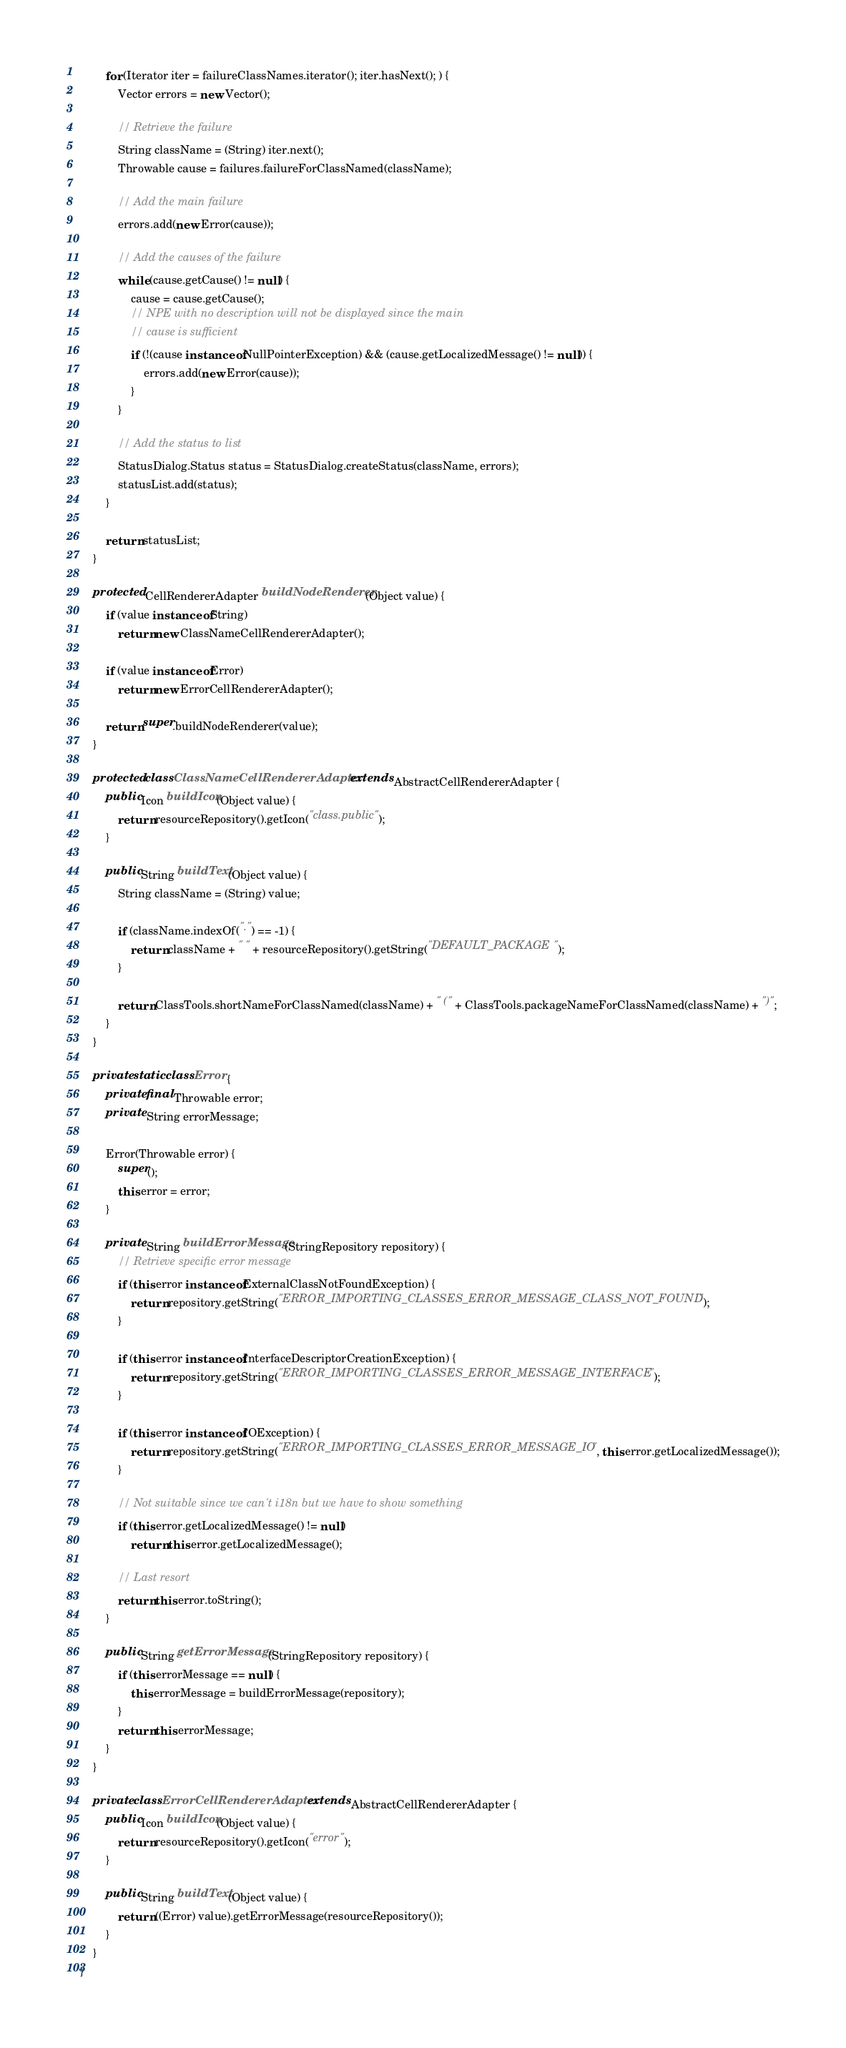<code> <loc_0><loc_0><loc_500><loc_500><_Java_>		for (Iterator iter = failureClassNames.iterator(); iter.hasNext(); ) {
			Vector errors = new Vector();

			// Retrieve the failure
			String className = (String) iter.next();
			Throwable cause = failures.failureForClassNamed(className);

			// Add the main failure
			errors.add(new Error(cause));

			// Add the causes of the failure
			while (cause.getCause() != null) {
				cause = cause.getCause();
				// NPE with no description will not be displayed since the main
				// cause is sufficient
				if (!(cause instanceof NullPointerException) && (cause.getLocalizedMessage() != null)) {
					errors.add(new Error(cause));
				}
			}

			// Add the status to list
			StatusDialog.Status status = StatusDialog.createStatus(className, errors);
			statusList.add(status);
		}

		return statusList;
	}

	protected CellRendererAdapter buildNodeRenderer(Object value) {
		if (value instanceof String)
			return new ClassNameCellRendererAdapter();

		if (value instanceof Error)
			return new ErrorCellRendererAdapter();

		return super.buildNodeRenderer(value);
	}

	protected class ClassNameCellRendererAdapter extends AbstractCellRendererAdapter {
		public Icon buildIcon(Object value) {
			return resourceRepository().getIcon("class.public");
		}

		public String buildText(Object value) {
			String className = (String) value;

			if (className.indexOf(".") == -1) {
				return className + " " + resourceRepository().getString("DEFAULT_PACKAGE");
			}

			return ClassTools.shortNameForClassNamed(className) + " (" + ClassTools.packageNameForClassNamed(className) + ")";
		}
	}

	private static class Error {
		private final Throwable error;
		private String errorMessage;

		Error(Throwable error) {
			super();
			this.error = error;
		}

		private String buildErrorMessage(StringRepository repository) {
			// Retrieve specific error message
			if (this.error instanceof ExternalClassNotFoundException) {
				return repository.getString("ERROR_IMPORTING_CLASSES_ERROR_MESSAGE_CLASS_NOT_FOUND");
			}

			if (this.error instanceof InterfaceDescriptorCreationException) {
				return repository.getString("ERROR_IMPORTING_CLASSES_ERROR_MESSAGE_INTERFACE");
			}

			if (this.error instanceof IOException) {
				return repository.getString("ERROR_IMPORTING_CLASSES_ERROR_MESSAGE_IO", this.error.getLocalizedMessage());
			}

			// Not suitable since we can't i18n but we have to show something
			if (this.error.getLocalizedMessage() != null)
				return this.error.getLocalizedMessage();

			// Last resort
			return this.error.toString();
		}

		public String getErrorMessage(StringRepository repository) {
			if (this.errorMessage == null) {
				this.errorMessage = buildErrorMessage(repository);
			}
			return this.errorMessage;
		}
	}

	private class ErrorCellRendererAdapter extends AbstractCellRendererAdapter {
		public Icon buildIcon(Object value) {
			return resourceRepository().getIcon("error");
		}

		public String buildText(Object value) {
			return ((Error) value).getErrorMessage(resourceRepository());
		}
	}
}
</code> 